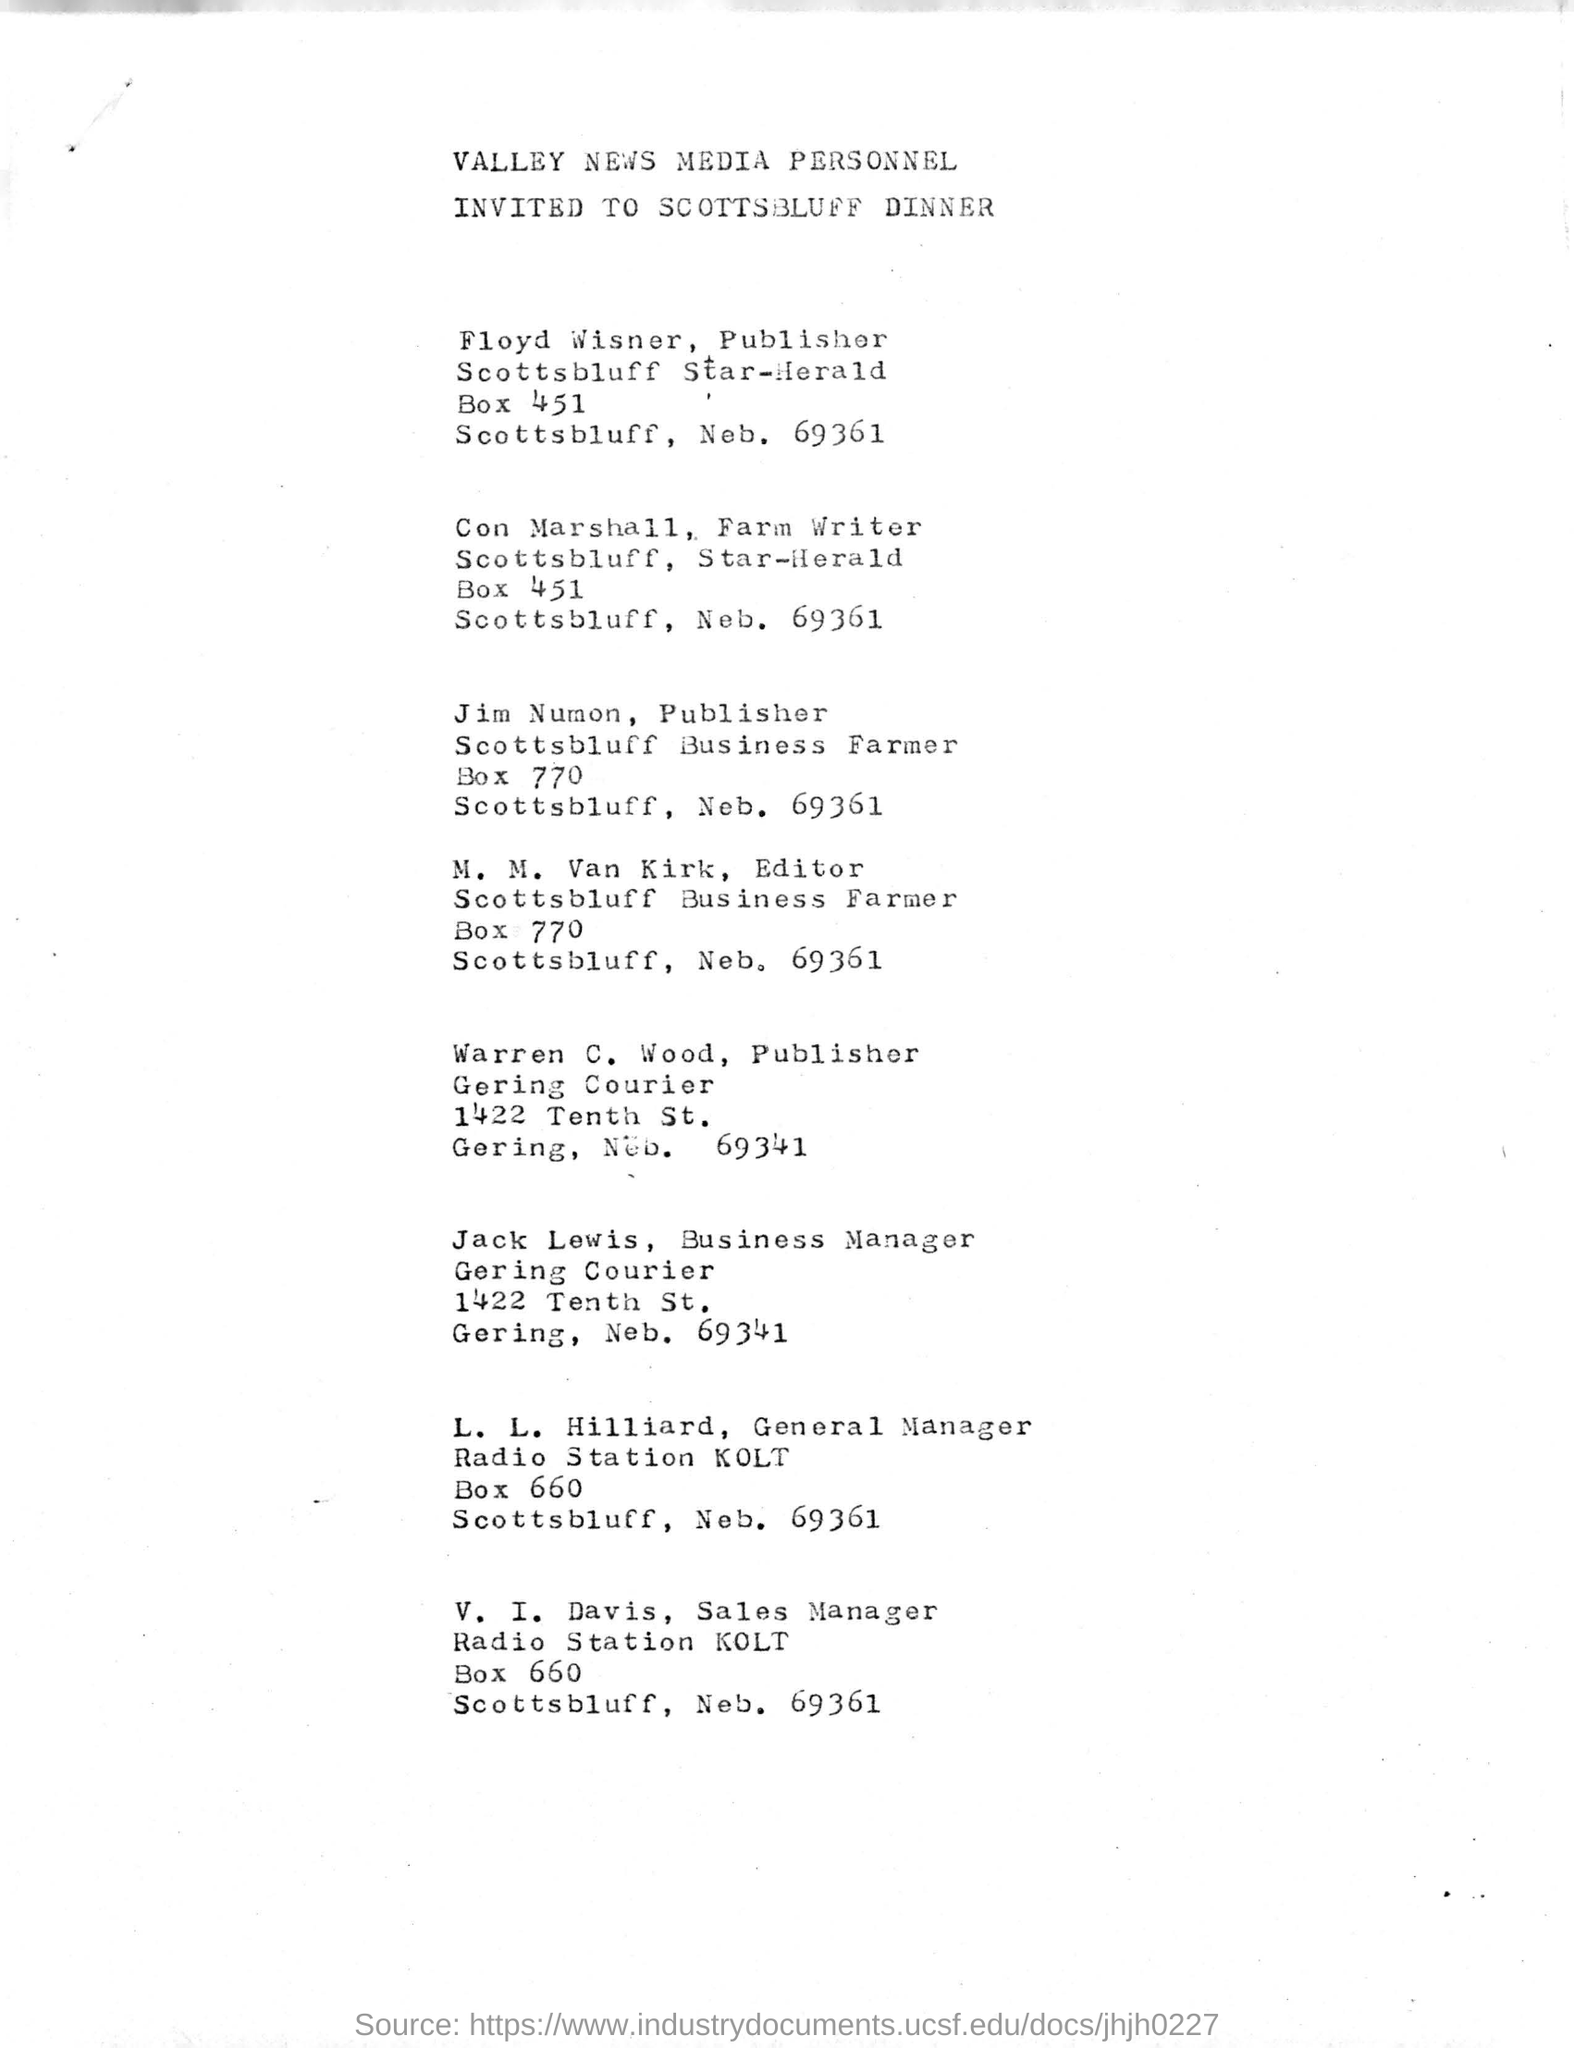Specify some key components in this picture. The address of Floyd Wisner is located at Scottsbluff Star-Herald Box 451. The last name on this document is V. I. DAVIS. Valley News Media personnel have been invited to attend a dinner in Scottsbluff. The second-to-last name in this document is L. L. Hilliard. 